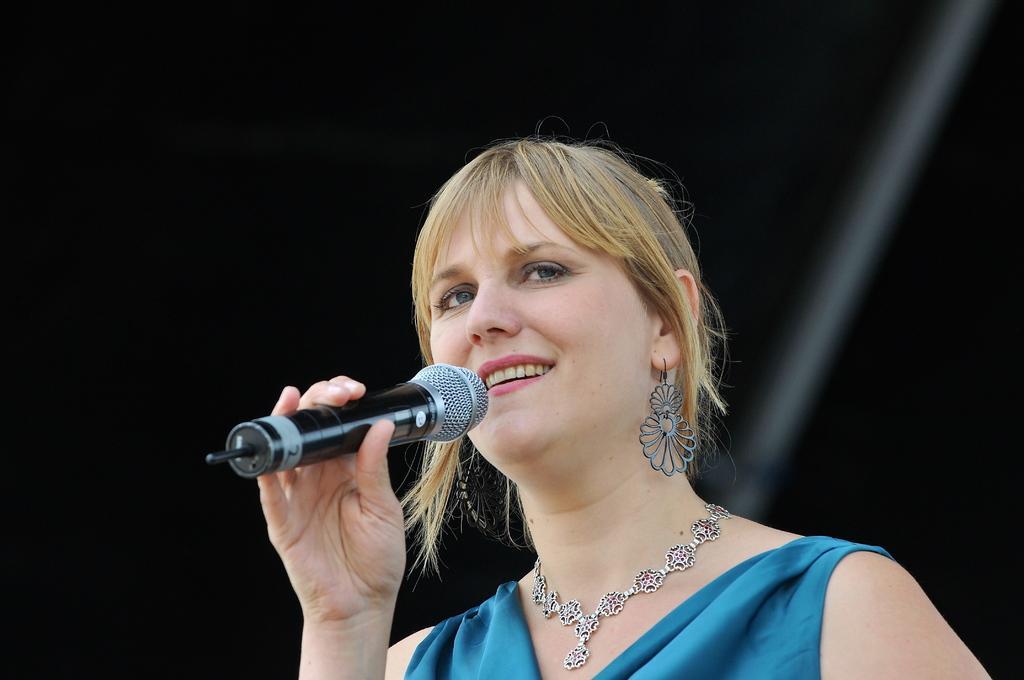Can you describe this image briefly? There is a woman, smiling, holding a mic in her hand. She is wearing a necklace. In the background, there is dark. 